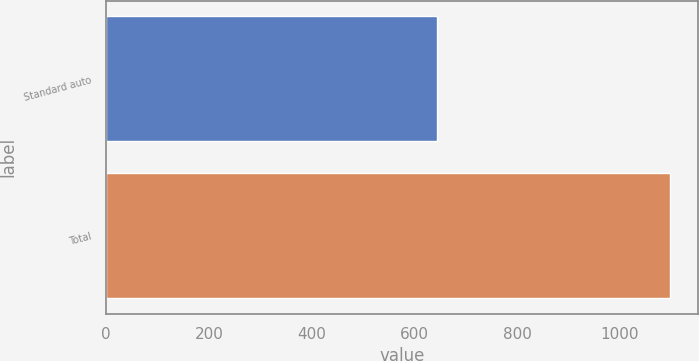<chart> <loc_0><loc_0><loc_500><loc_500><bar_chart><fcel>Standard auto<fcel>Total<nl><fcel>644<fcel>1097<nl></chart> 